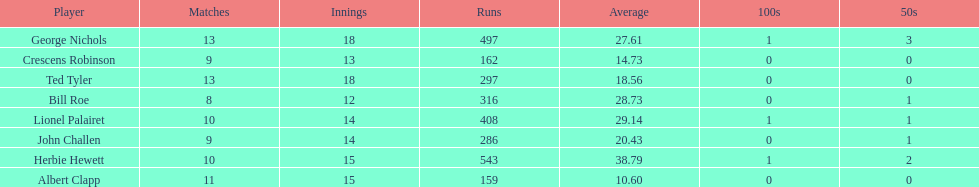How many more runs does john have than albert? 127. 